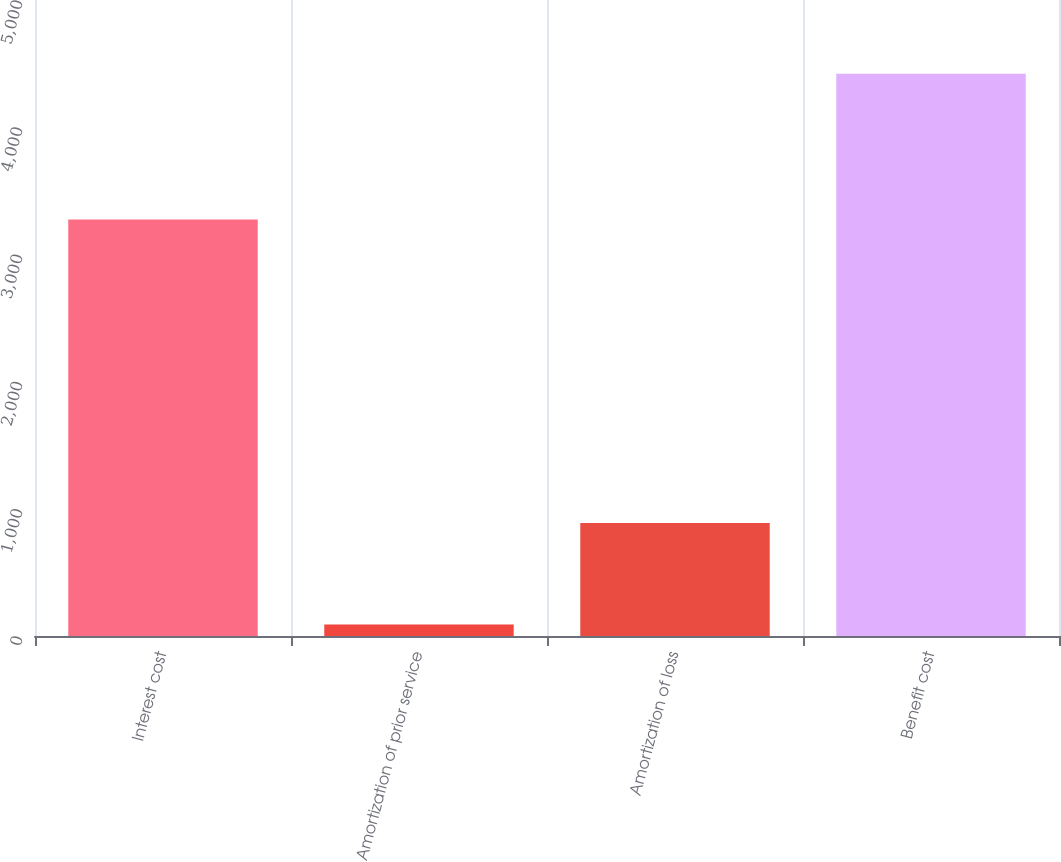<chart> <loc_0><loc_0><loc_500><loc_500><bar_chart><fcel>Interest cost<fcel>Amortization of prior service<fcel>Amortization of loss<fcel>Benefit cost<nl><fcel>3274<fcel>91<fcel>888<fcel>4420<nl></chart> 